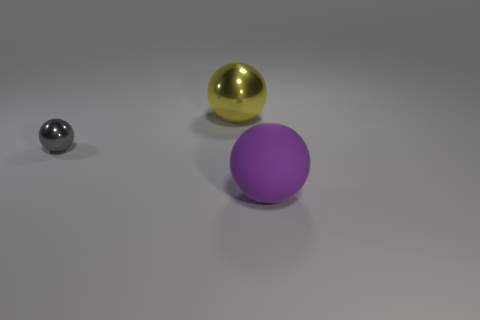The gray object that is the same shape as the purple object is what size?
Provide a short and direct response. Small. What color is the other metallic object that is the same shape as the large metal object?
Keep it short and to the point. Gray. Does the object that is right of the large yellow sphere have the same size as the metal thing that is behind the tiny gray object?
Provide a succinct answer. Yes. Is the size of the matte thing the same as the metal thing behind the tiny gray shiny sphere?
Your answer should be compact. Yes. The purple thing has what size?
Give a very brief answer. Large. There is a sphere that is made of the same material as the big yellow object; what is its color?
Offer a very short reply. Gray. How many other purple things have the same material as the small thing?
Provide a succinct answer. 0. What number of things are either small gray cylinders or objects behind the large purple matte ball?
Ensure brevity in your answer.  2. Do the big thing in front of the large yellow ball and the small thing have the same material?
Provide a succinct answer. No. What is the color of the other rubber sphere that is the same size as the yellow sphere?
Your answer should be compact. Purple. 